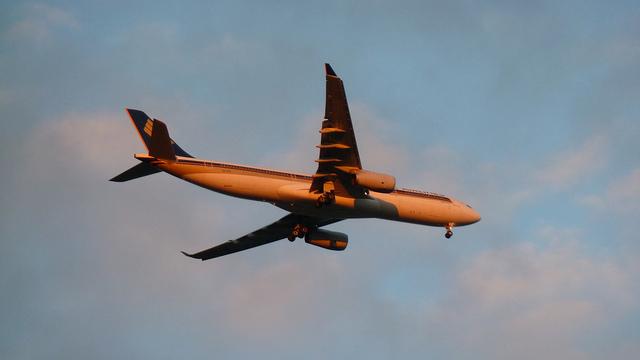What word is on the underside of the wings?
Quick response, please. None. Is the picture taken at night time or day time?
Give a very brief answer. Day. Is the plane high in the sky?
Give a very brief answer. Yes. Do you see clouds?
Be succinct. Yes. Why do planes fly like this at times?
Quick response, please. Landing. Does the image of the plane in the sky look realistic?
Give a very brief answer. Yes. What color is the plane?
Quick response, please. Orange. What is the color of the plane?
Short answer required. White. 